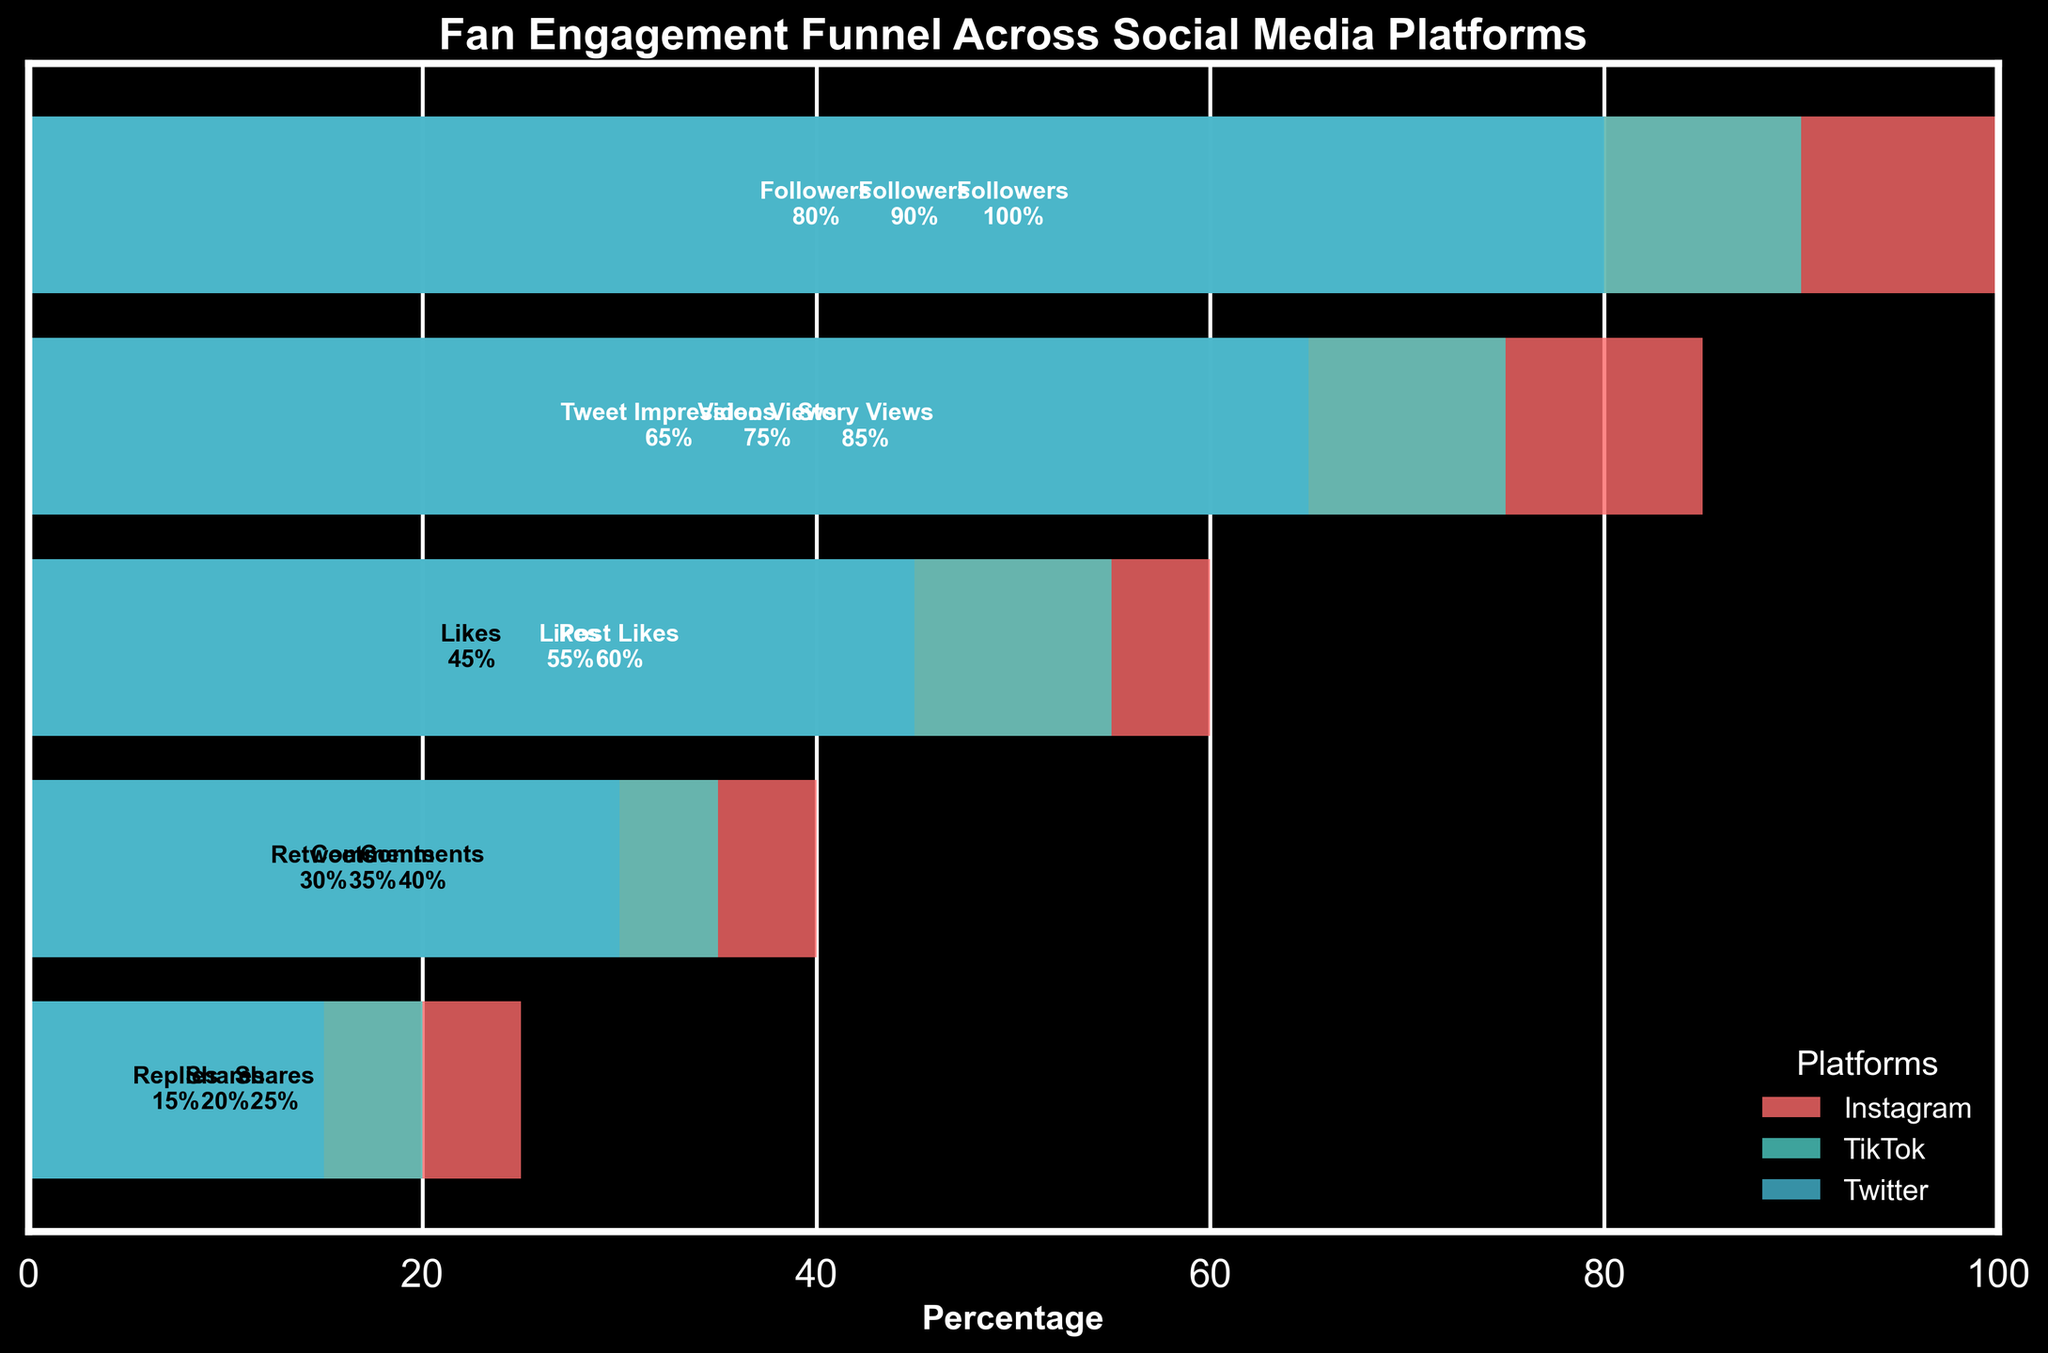What is the title of the figure? The title is usually displayed at the top of the figure and gives an overview of what the chart is about. The title here is "Fan Engagement Funnel Across Social Media Platforms".
Answer: Fan Engagement Funnel Across Social Media Platforms Which platform has the highest percentage of "Post Likes"? To find this, look for the "Post Likes" label and check the associated percentage for different platforms. Instagram has "Post Likes" at 60%, which is the highest among all platforms.
Answer: Instagram What is the difference in "Followers" percentage between Instagram and Twitter? Look at the "Followers" percentage for both platforms: Instagram (100%) and Twitter (80%). Subtract the percentage of Twitter from Instagram: 100% - 80% = 20%.
Answer: 20% Which engagement level has the lowest percentage on TikTok? Locate the percentages under the TikTok section, and find the lowest value: "Shares" at 20%.
Answer: Shares How does the "Likes" engagement percentage compare between TikTok and Twitter? Identify the "Likes" percentage for both platforms: TikTok (55%) and Twitter (45%). TikTok has a higher percentage than Twitter.
Answer: TikTok has a higher percentage What is the combined percentage sum of "Comments" across all platforms? Add the "Comments" percentage for each platform: Instagram (40%) + TikTok (35%) + Twitter (15%) = 90%.
Answer: 90% What is the average percentage of "Shares" across all platforms? Add the "Shares" percentage for each platform then divide by the number of platforms: (25% + 20% + 30%) / 3 = 25%.
Answer: 25% In which platform does "Video Views" appear, and what is its percentage? "Video Views" is unique to TikTok, and its percentage is listed as 75%.
Answer: TikTok, 75% Rank the platforms based on the highest to lowest percentage for "Story Views". Identify the "Story Views" percentage for each platform: Instagram has 85%, TikTok and Twitter do not have "Story Views". Therefore, Instagram has the highest and only value.
Answer: Instagram 